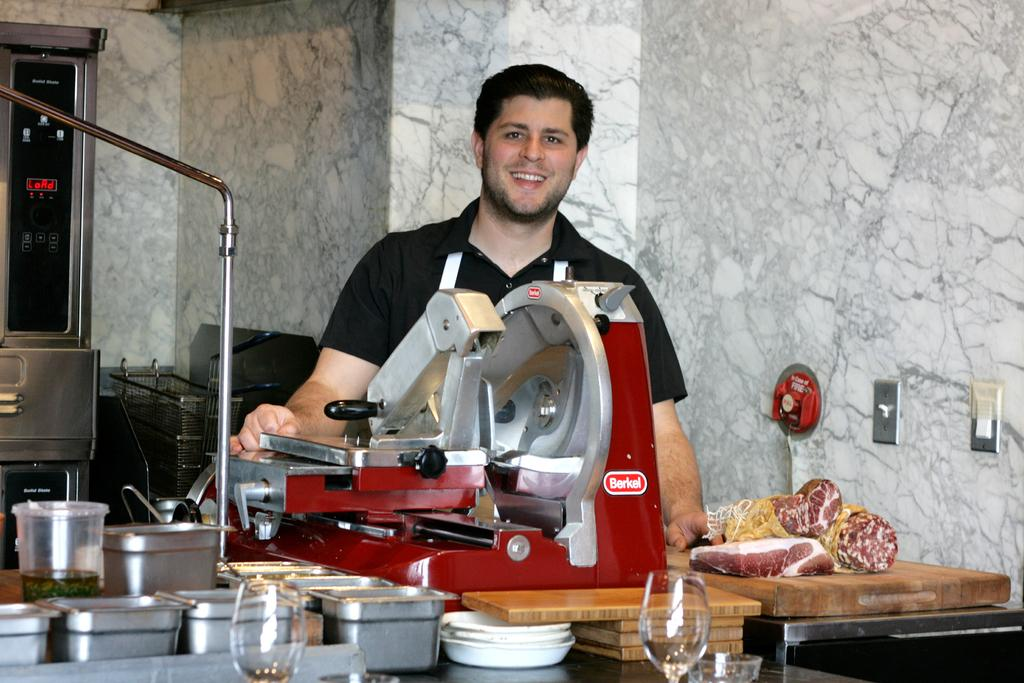<image>
Summarize the visual content of the image. A man stands in front of a Berkel brand food preparation machine. 